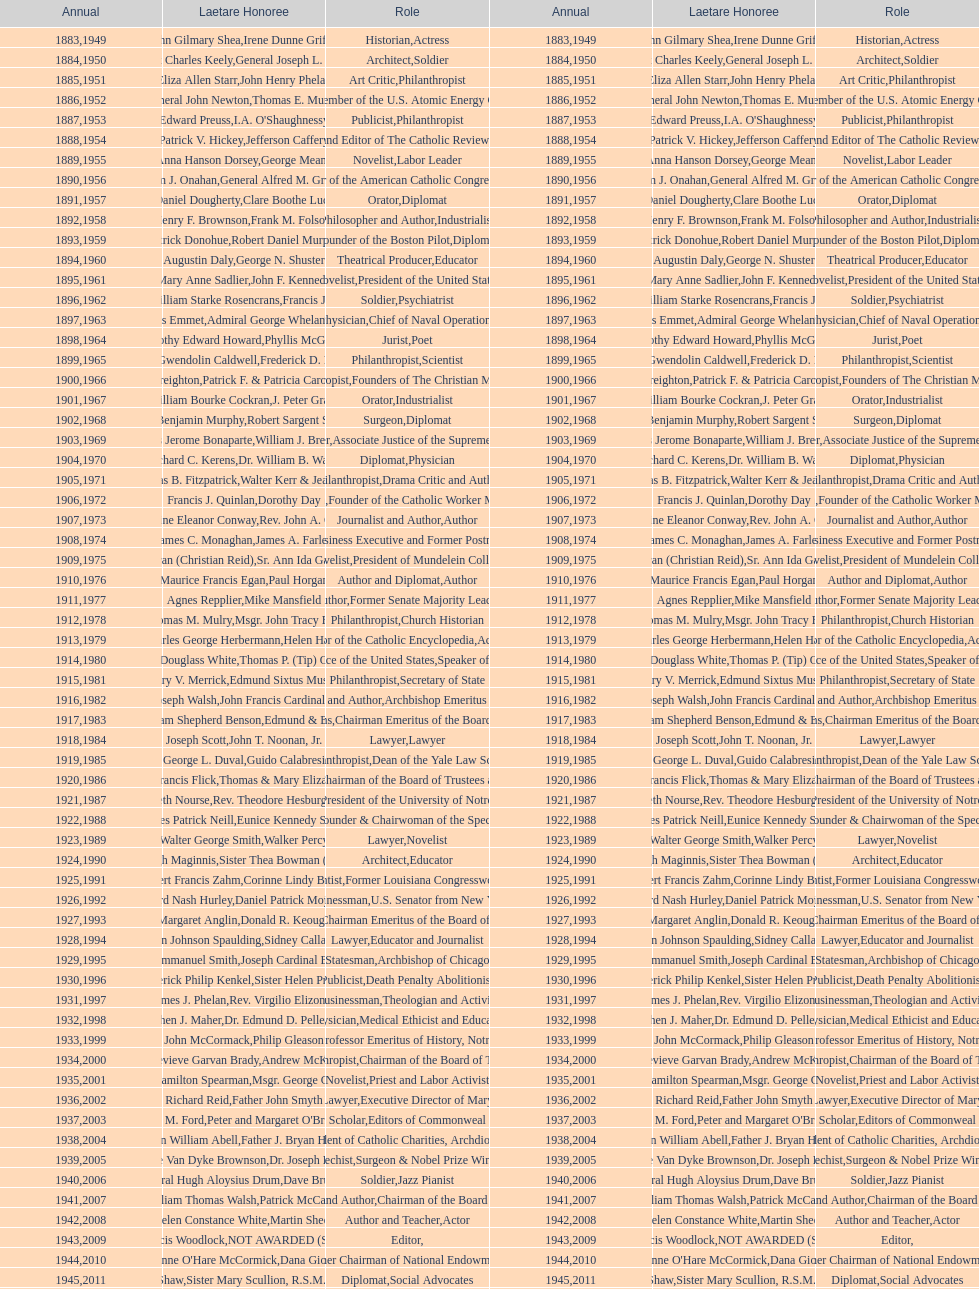Who won the medal after thomas e. murray in 1952? I.A. O'Shaughnessy. I'm looking to parse the entire table for insights. Could you assist me with that? {'header': ['Annual', 'Laetare Honoree', 'Role', 'Annual', 'Laetare Honoree', 'Role'], 'rows': [['1883', 'John Gilmary Shea', 'Historian', '1949', 'Irene Dunne Griffin', 'Actress'], ['1884', 'Patrick Charles Keely', 'Architect', '1950', 'General Joseph L. Collins', 'Soldier'], ['1885', 'Eliza Allen Starr', 'Art Critic', '1951', 'John Henry Phelan', 'Philanthropist'], ['1886', 'General John Newton', 'Engineer', '1952', 'Thomas E. Murray', 'Member of the U.S. Atomic Energy Commission'], ['1887', 'Edward Preuss', 'Publicist', '1953', "I.A. O'Shaughnessy", 'Philanthropist'], ['1888', 'Patrick V. Hickey', 'Founder and Editor of The Catholic Review', '1954', 'Jefferson Caffery', 'Diplomat'], ['1889', 'Anna Hanson Dorsey', 'Novelist', '1955', 'George Meany', 'Labor Leader'], ['1890', 'William J. Onahan', 'Organizer of the American Catholic Congress', '1956', 'General Alfred M. Gruenther', 'Soldier'], ['1891', 'Daniel Dougherty', 'Orator', '1957', 'Clare Boothe Luce', 'Diplomat'], ['1892', 'Henry F. Brownson', 'Philosopher and Author', '1958', 'Frank M. Folsom', 'Industrialist'], ['1893', 'Patrick Donohue', 'Founder of the Boston Pilot', '1959', 'Robert Daniel Murphy', 'Diplomat'], ['1894', 'Augustin Daly', 'Theatrical Producer', '1960', 'George N. Shuster', 'Educator'], ['1895', 'Mary Anne Sadlier', 'Novelist', '1961', 'John F. Kennedy', 'President of the United States'], ['1896', 'General William Starke Rosencrans', 'Soldier', '1962', 'Francis J. Braceland', 'Psychiatrist'], ['1897', 'Thomas Addis Emmet', 'Physician', '1963', 'Admiral George Whelan Anderson, Jr.', 'Chief of Naval Operations'], ['1898', 'Timothy Edward Howard', 'Jurist', '1964', 'Phyllis McGinley', 'Poet'], ['1899', 'Mary Gwendolin Caldwell', 'Philanthropist', '1965', 'Frederick D. Rossini', 'Scientist'], ['1900', 'John A. Creighton', 'Philanthropist', '1966', 'Patrick F. & Patricia Caron Crowley', 'Founders of The Christian Movement'], ['1901', 'William Bourke Cockran', 'Orator', '1967', 'J. Peter Grace', 'Industrialist'], ['1902', 'John Benjamin Murphy', 'Surgeon', '1968', 'Robert Sargent Shriver', 'Diplomat'], ['1903', 'Charles Jerome Bonaparte', 'Lawyer', '1969', 'William J. Brennan Jr.', 'Associate Justice of the Supreme Court'], ['1904', 'Richard C. Kerens', 'Diplomat', '1970', 'Dr. William B. Walsh', 'Physician'], ['1905', 'Thomas B. Fitzpatrick', 'Philanthropist', '1971', 'Walter Kerr & Jean Kerr', 'Drama Critic and Author'], ['1906', 'Francis J. Quinlan', 'Physician', '1972', 'Dorothy Day', 'Founder of the Catholic Worker Movement'], ['1907', 'Katherine Eleanor Conway', 'Journalist and Author', '1973', "Rev. John A. O'Brien", 'Author'], ['1908', 'James C. Monaghan', 'Economist', '1974', 'James A. Farley', 'Business Executive and Former Postmaster General'], ['1909', 'Frances Tieran (Christian Reid)', 'Novelist', '1975', 'Sr. Ann Ida Gannon, BMV', 'President of Mundelein College'], ['1910', 'Maurice Francis Egan', 'Author and Diplomat', '1976', 'Paul Horgan', 'Author'], ['1911', 'Agnes Repplier', 'Author', '1977', 'Mike Mansfield', 'Former Senate Majority Leader'], ['1912', 'Thomas M. Mulry', 'Philanthropist', '1978', 'Msgr. John Tracy Ellis', 'Church Historian'], ['1913', 'Charles George Herbermann', 'Editor of the Catholic Encyclopedia', '1979', 'Helen Hayes', 'Actress'], ['1914', 'Edward Douglass White', 'Chief Justice of the United States', '1980', "Thomas P. (Tip) O'Neill Jr.", 'Speaker of the House'], ['1915', 'Mary V. Merrick', 'Philanthropist', '1981', 'Edmund Sixtus Muskie', 'Secretary of State'], ['1916', 'James Joseph Walsh', 'Physician and Author', '1982', 'John Francis Cardinal Dearden', 'Archbishop Emeritus of Detroit'], ['1917', 'Admiral William Shepherd Benson', 'Chief of Naval Operations', '1983', 'Edmund & Evelyn Stephan', 'Chairman Emeritus of the Board of Trustees and his wife'], ['1918', 'Joseph Scott', 'Lawyer', '1984', 'John T. Noonan, Jr.', 'Lawyer'], ['1919', 'George L. Duval', 'Philanthropist', '1985', 'Guido Calabresi', 'Dean of the Yale Law School'], ['1920', 'Lawrence Francis Flick', 'Physician', '1986', 'Thomas & Mary Elizabeth Carney', 'Chairman of the Board of Trustees and his wife'], ['1921', 'Elizabeth Nourse', 'Artist', '1987', 'Rev. Theodore Hesburgh, CSC', 'President of the University of Notre Dame'], ['1922', 'Charles Patrick Neill', 'Economist', '1988', 'Eunice Kennedy Shriver', 'Founder & Chairwoman of the Special Olympics'], ['1923', 'Walter George Smith', 'Lawyer', '1989', 'Walker Percy', 'Novelist'], ['1924', 'Charles Donagh Maginnis', 'Architect', '1990', 'Sister Thea Bowman (posthumously)', 'Educator'], ['1925', 'Albert Francis Zahm', 'Scientist', '1991', 'Corinne Lindy Boggs', 'Former Louisiana Congresswoman'], ['1926', 'Edward Nash Hurley', 'Businessman', '1992', 'Daniel Patrick Moynihan', 'U.S. Senator from New York'], ['1927', 'Margaret Anglin', 'Actress', '1993', 'Donald R. Keough', 'Chairman Emeritus of the Board of Trustees'], ['1928', 'John Johnson Spaulding', 'Lawyer', '1994', 'Sidney Callahan', 'Educator and Journalist'], ['1929', 'Alfred Emmanuel Smith', 'Statesman', '1995', 'Joseph Cardinal Bernardin', 'Archbishop of Chicago'], ['1930', 'Frederick Philip Kenkel', 'Publicist', '1996', 'Sister Helen Prejean', 'Death Penalty Abolitionist'], ['1931', 'James J. Phelan', 'Businessman', '1997', 'Rev. Virgilio Elizondo', 'Theologian and Activist'], ['1932', 'Stephen J. Maher', 'Physician', '1998', 'Dr. Edmund D. Pellegrino', 'Medical Ethicist and Educator'], ['1933', 'John McCormack', 'Artist', '1999', 'Philip Gleason', 'Professor Emeritus of History, Notre Dame'], ['1934', 'Genevieve Garvan Brady', 'Philanthropist', '2000', 'Andrew McKenna', 'Chairman of the Board of Trustees'], ['1935', 'Francis Hamilton Spearman', 'Novelist', '2001', 'Msgr. George G. Higgins', 'Priest and Labor Activist'], ['1936', 'Richard Reid', 'Journalist and Lawyer', '2002', 'Father John Smyth', 'Executive Director of Maryville Academy'], ['1937', 'Jeremiah D. M. Ford', 'Scholar', '2003', "Peter and Margaret O'Brien Steinfels", 'Editors of Commonweal'], ['1938', 'Irvin William Abell', 'Surgeon', '2004', 'Father J. Bryan Hehir', 'President of Catholic Charities, Archdiocese of Boston'], ['1939', 'Josephine Van Dyke Brownson', 'Catechist', '2005', 'Dr. Joseph E. Murray', 'Surgeon & Nobel Prize Winner'], ['1940', 'General Hugh Aloysius Drum', 'Soldier', '2006', 'Dave Brubeck', 'Jazz Pianist'], ['1941', 'William Thomas Walsh', 'Journalist and Author', '2007', 'Patrick McCartan', 'Chairman of the Board of Trustees'], ['1942', 'Helen Constance White', 'Author and Teacher', '2008', 'Martin Sheen', 'Actor'], ['1943', 'Thomas Francis Woodlock', 'Editor', '2009', 'NOT AWARDED (SEE BELOW)', ''], ['1944', "Anne O'Hare McCormick", 'Journalist', '2010', 'Dana Gioia', 'Former Chairman of National Endowment for the Arts'], ['1945', 'Gardiner Howland Shaw', 'Diplomat', '2011', 'Sister Mary Scullion, R.S.M., & Joan McConnon', 'Social Advocates'], ['1946', 'Carlton J. H. Hayes', 'Historian and Diplomat', '2012', 'Ken Hackett', 'Former President of Catholic Relief Services'], ['1947', 'William G. Bruce', 'Publisher and Civic Leader', '2013', 'Sister Susanne Gallagher, S.P.\\nSister Mary Therese Harrington, S.H.\\nRev. James H. McCarthy', 'Founders of S.P.R.E.D. (Special Religious Education Development Network)'], ['1948', 'Frank C. Walker', 'Postmaster General and Civic Leader', '2014', 'Kenneth R. Miller', 'Professor of Biology at Brown University']]} 